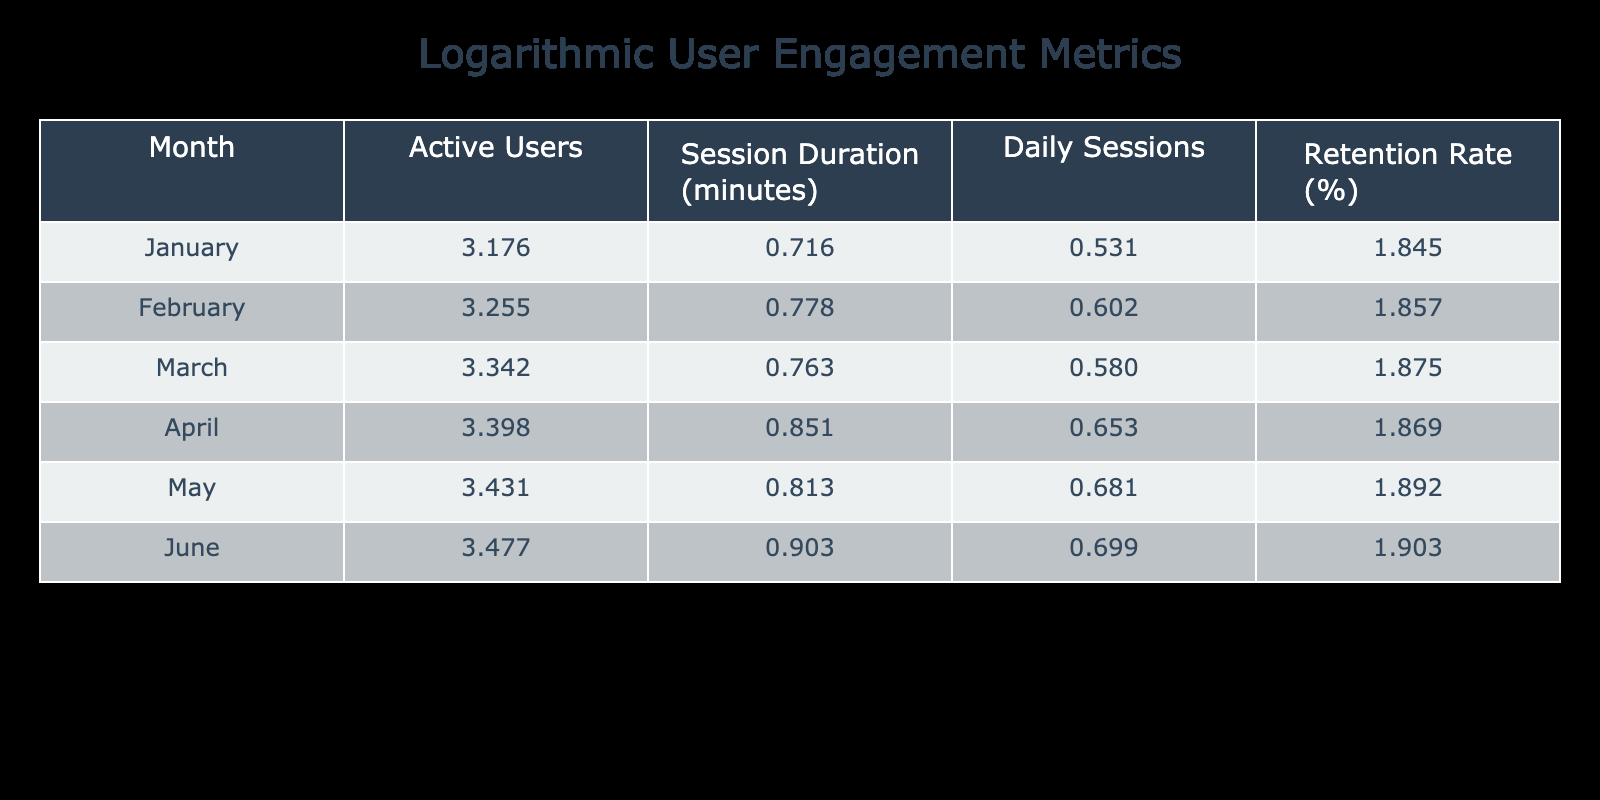What is the session duration in June? In the table under the "Session Duration (minutes)" column, the value for June is clearly indicated as 8.0.
Answer: 8.0 What was the retention rate in March? Referring to the "Retention Rate (%)" column, the value for March is listed as 75%.
Answer: 75% Which month had the highest number of active users? Looking at the "Active Users" column, June has the highest value at 3000.
Answer: June Calculate the average session duration over the six months. Adding the session durations for each month: (5.2 + 6.0 + 5.8 + 7.1 + 6.5 + 8.0) = 38.6. Then dividing by the number of months (6) gives an average of 38.6 / 6 = 6.4333, rounded to three decimal places it's 6.433.
Answer: 6.433 Is the retention rate consistently higher than 70% throughout the six months? The retention rates are 70, 72, 75, 74, 78, and 80. Since all these values are above 70%, the answer is yes.
Answer: Yes How much did the daily sessions increase from January to June? The daily sessions in January are 3.4 and in June are 5.0. The increase is calculated as 5.0 - 3.4 = 1.6.
Answer: 1.6 Which month had the greatest drop in retention compared to the previous month? The retention rates are 70, 72, 75, 74, 78, and 80. The greatest drop occurred from March (75%) to April (74%), which is a drop of 1%.
Answer: March to April What is the difference in active users between the months of January and May? The number of active users in January is 1500, and in May it is 2700. The difference is 2700 - 1500 = 1200.
Answer: 1200 